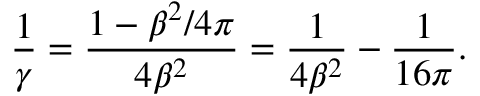Convert formula to latex. <formula><loc_0><loc_0><loc_500><loc_500>{ \frac { 1 } { \gamma } } = { \frac { 1 - \beta ^ { 2 } / 4 \pi } { 4 \beta ^ { 2 } } } = { \frac { 1 } { 4 \beta ^ { 2 } } } - { \frac { 1 } { 1 6 \pi } } .</formula> 